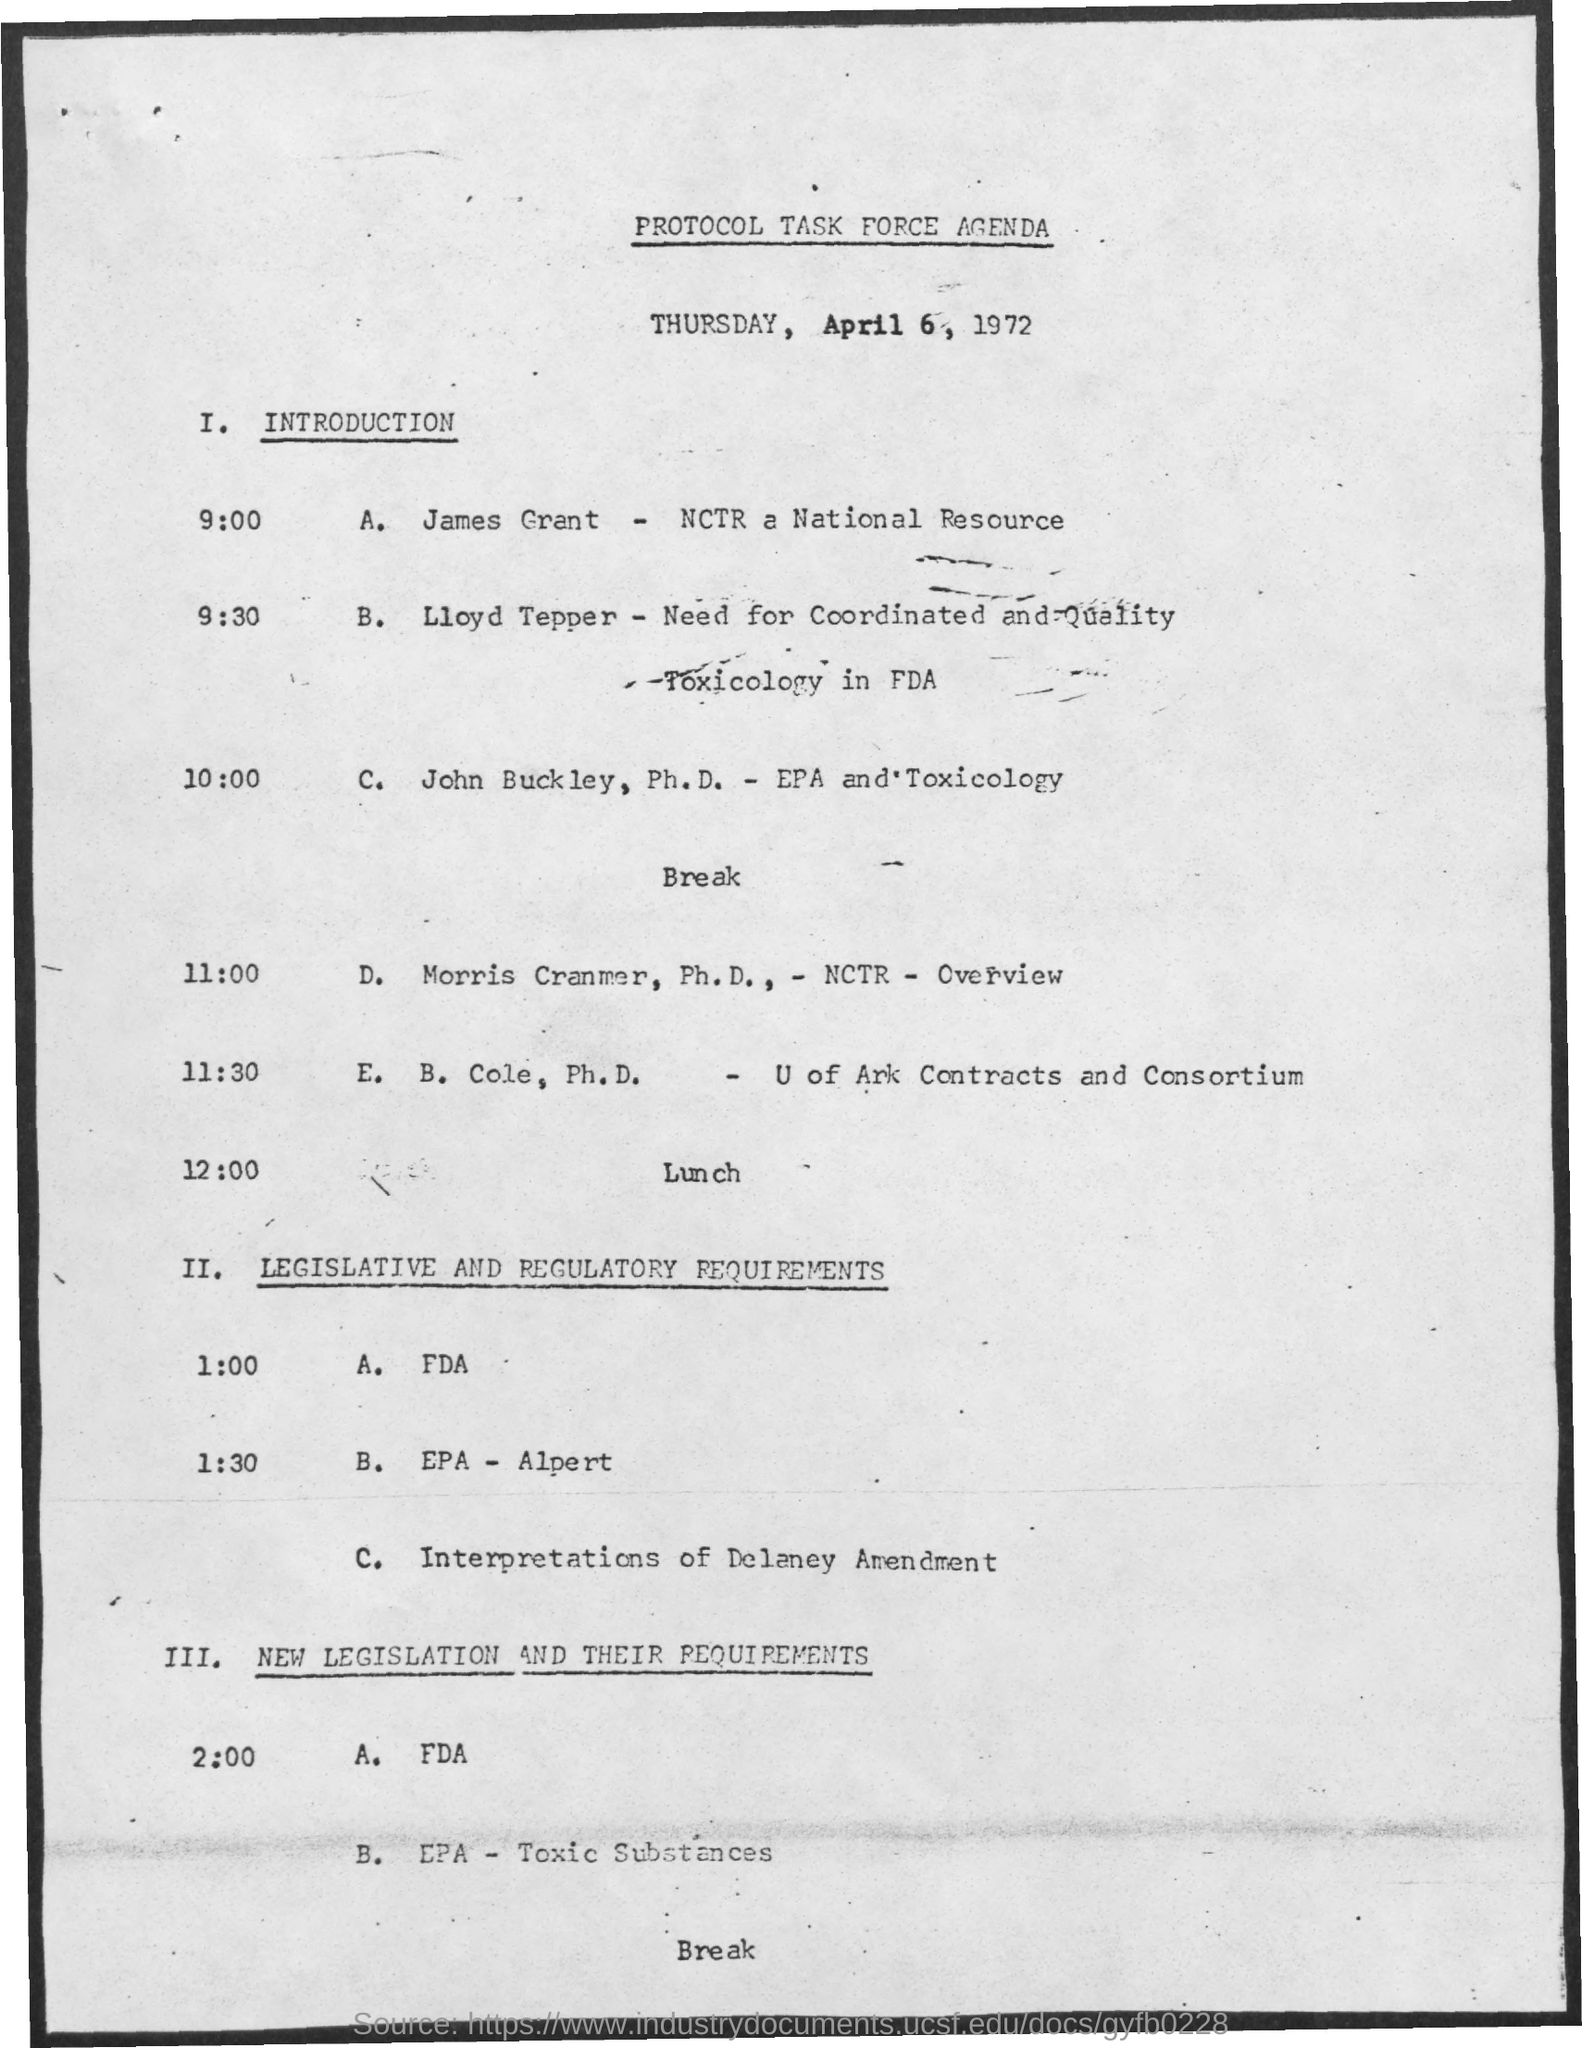What is the date mentioned in the document?
Make the answer very short. Thursday, april 6, 1972. 